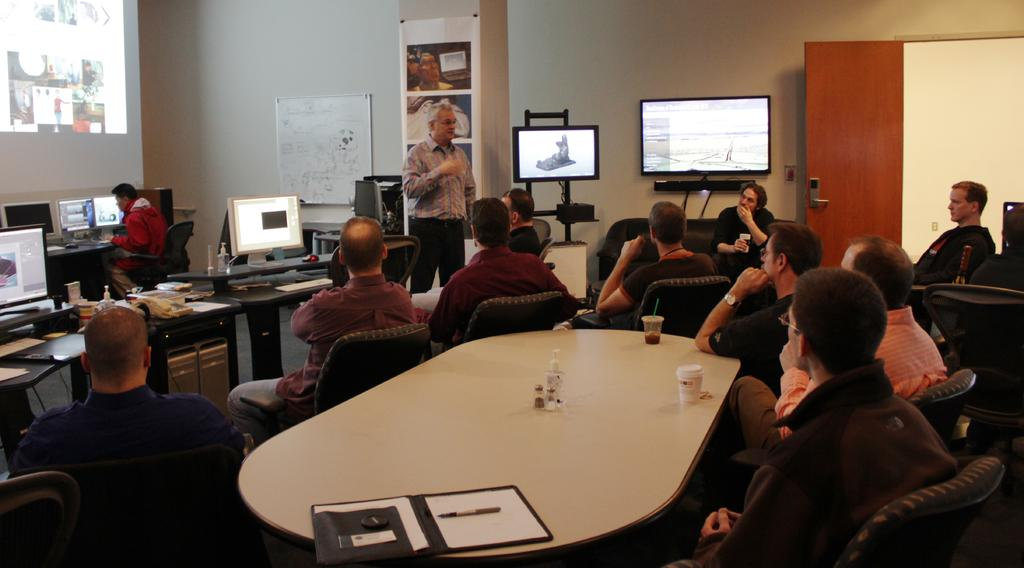What is the color of the wall in the image? The wall in the image is white. What can be seen on the wall in the image? There is a screen on the wall in the image. What else is present on the wall in the image? There is a board on the wall in the image. What devices are on the table in the image? There are laptops on a table in the image. What are the people in the image doing? The people in the image are sitting on chairs. What type of pancake is being served to the people in the image? There is no pancake present in the image; the devices on the table are laptops. 